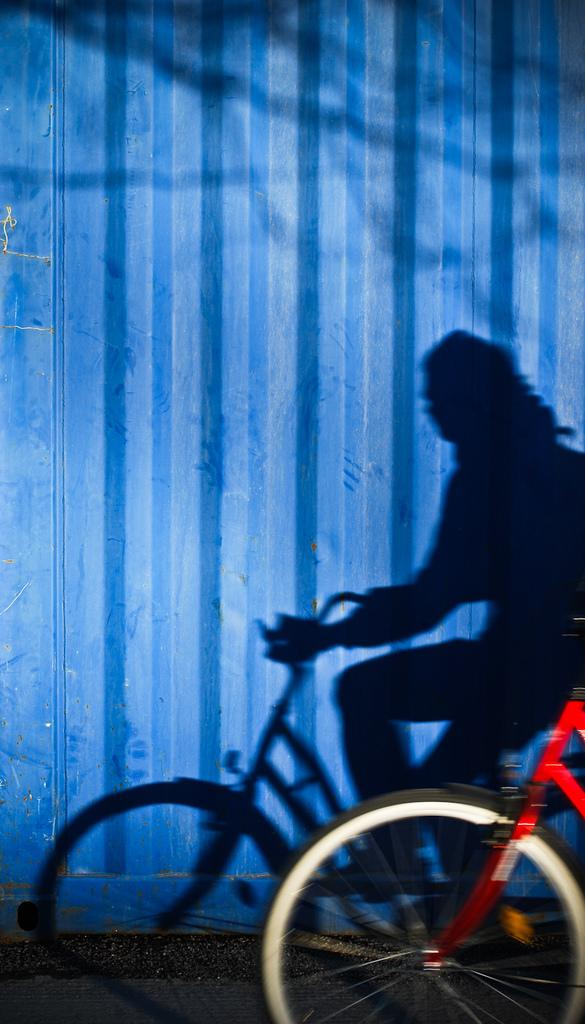What mode of transportation is in the picture? There is a cycle in the picture. Can you describe the person in the image? The shadow of a person sitting on the bicycle is visible. What color is the wall in the background? The wall in the background is blue. What type of branch can be seen growing from the bicycle in the image? There is no branch growing from the bicycle in the image. What type of work is the person on the bicycle doing in the image? The image does not show the person on the bicycle performing any work. 